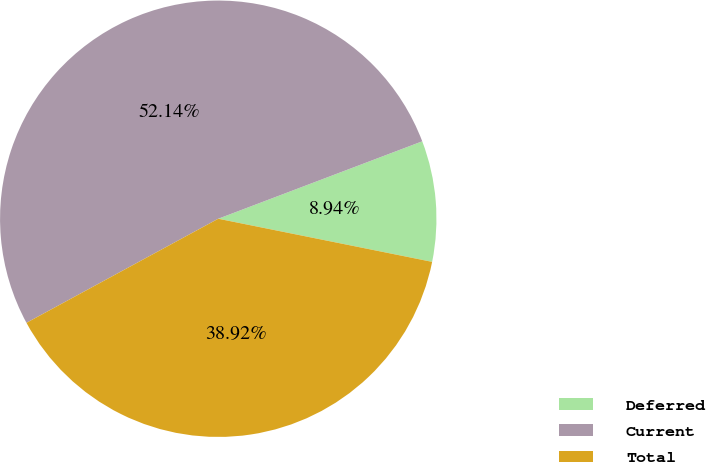Convert chart. <chart><loc_0><loc_0><loc_500><loc_500><pie_chart><fcel>Deferred<fcel>Current<fcel>Total<nl><fcel>8.94%<fcel>52.14%<fcel>38.92%<nl></chart> 